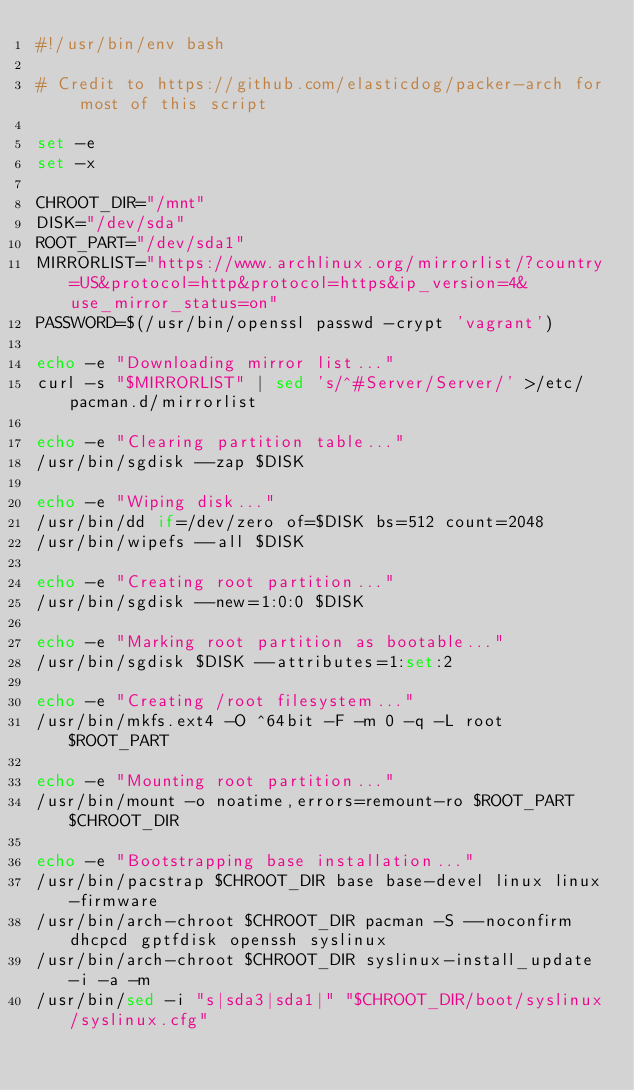<code> <loc_0><loc_0><loc_500><loc_500><_Bash_>#!/usr/bin/env bash

# Credit to https://github.com/elasticdog/packer-arch for most of this script

set -e
set -x

CHROOT_DIR="/mnt"
DISK="/dev/sda"
ROOT_PART="/dev/sda1"
MIRRORLIST="https://www.archlinux.org/mirrorlist/?country=US&protocol=http&protocol=https&ip_version=4&use_mirror_status=on"
PASSWORD=$(/usr/bin/openssl passwd -crypt 'vagrant')

echo -e "Downloading mirror list..."
curl -s "$MIRRORLIST" | sed 's/^#Server/Server/' >/etc/pacman.d/mirrorlist

echo -e "Clearing partition table..."
/usr/bin/sgdisk --zap $DISK

echo -e "Wiping disk..."
/usr/bin/dd if=/dev/zero of=$DISK bs=512 count=2048
/usr/bin/wipefs --all $DISK

echo -e "Creating root partition..."
/usr/bin/sgdisk --new=1:0:0 $DISK

echo -e "Marking root partition as bootable..."
/usr/bin/sgdisk $DISK --attributes=1:set:2

echo -e "Creating /root filesystem..."
/usr/bin/mkfs.ext4 -O ^64bit -F -m 0 -q -L root $ROOT_PART

echo -e "Mounting root partition..."
/usr/bin/mount -o noatime,errors=remount-ro $ROOT_PART $CHROOT_DIR

echo -e "Bootstrapping base installation..."
/usr/bin/pacstrap $CHROOT_DIR base base-devel linux linux-firmware
/usr/bin/arch-chroot $CHROOT_DIR pacman -S --noconfirm dhcpcd gptfdisk openssh syslinux
/usr/bin/arch-chroot $CHROOT_DIR syslinux-install_update -i -a -m
/usr/bin/sed -i "s|sda3|sda1|" "$CHROOT_DIR/boot/syslinux/syslinux.cfg"</code> 